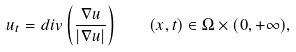Convert formula to latex. <formula><loc_0><loc_0><loc_500><loc_500>u _ { t } = d i v \left ( \frac { \nabla u } { | \nabla u | } \right ) \quad ( x , t ) \in \Omega \times ( 0 , + \infty ) ,</formula> 